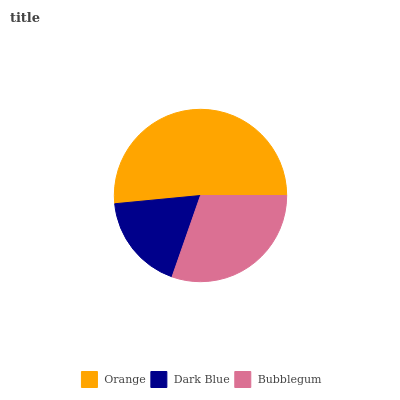Is Dark Blue the minimum?
Answer yes or no. Yes. Is Orange the maximum?
Answer yes or no. Yes. Is Bubblegum the minimum?
Answer yes or no. No. Is Bubblegum the maximum?
Answer yes or no. No. Is Bubblegum greater than Dark Blue?
Answer yes or no. Yes. Is Dark Blue less than Bubblegum?
Answer yes or no. Yes. Is Dark Blue greater than Bubblegum?
Answer yes or no. No. Is Bubblegum less than Dark Blue?
Answer yes or no. No. Is Bubblegum the high median?
Answer yes or no. Yes. Is Bubblegum the low median?
Answer yes or no. Yes. Is Orange the high median?
Answer yes or no. No. Is Orange the low median?
Answer yes or no. No. 